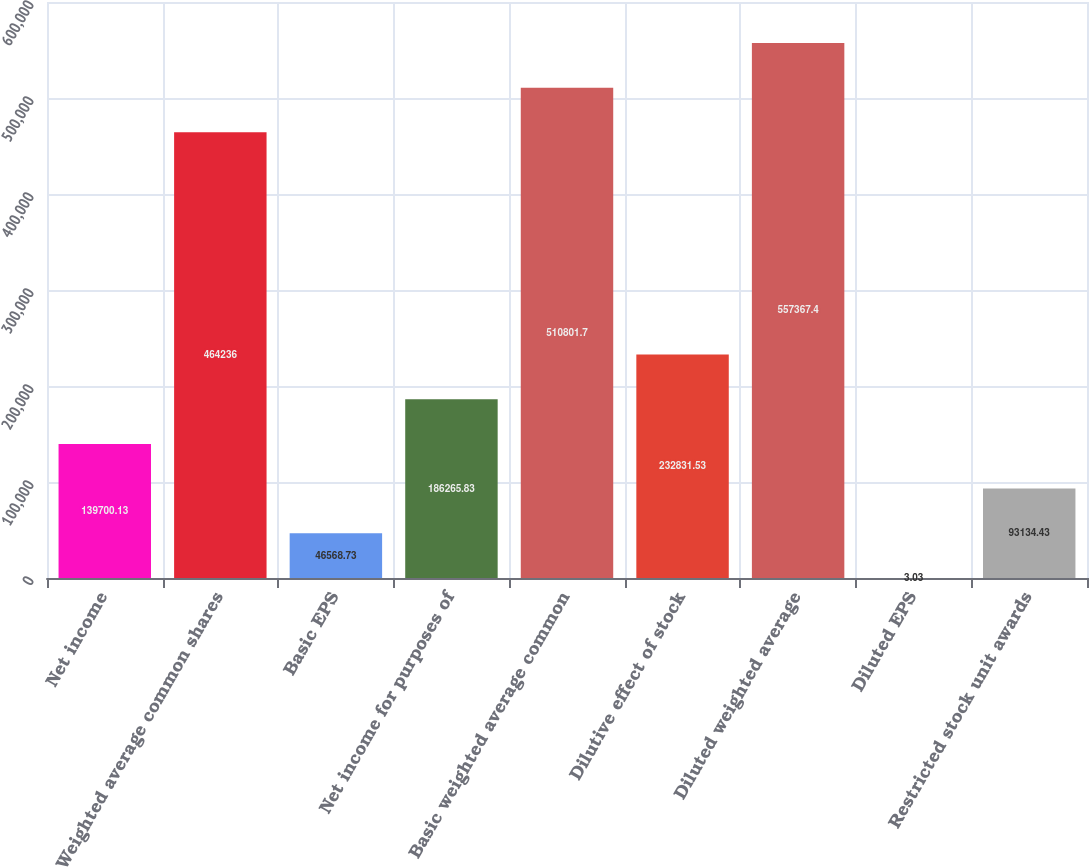Convert chart to OTSL. <chart><loc_0><loc_0><loc_500><loc_500><bar_chart><fcel>Net income<fcel>Weighted average common shares<fcel>Basic EPS<fcel>Net income for purposes of<fcel>Basic weighted average common<fcel>Dilutive effect of stock<fcel>Diluted weighted average<fcel>Diluted EPS<fcel>Restricted stock unit awards<nl><fcel>139700<fcel>464236<fcel>46568.7<fcel>186266<fcel>510802<fcel>232832<fcel>557367<fcel>3.03<fcel>93134.4<nl></chart> 